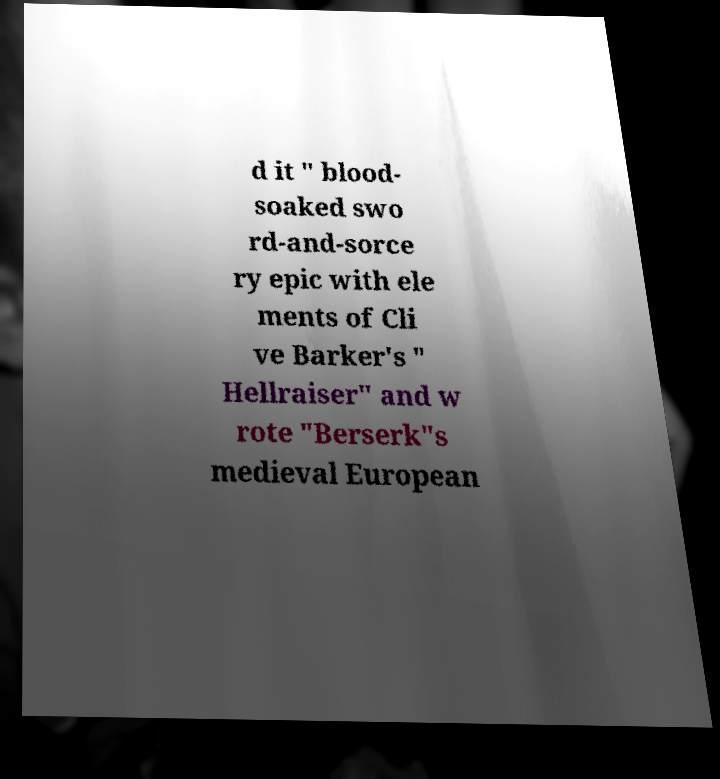Can you read and provide the text displayed in the image?This photo seems to have some interesting text. Can you extract and type it out for me? d it " blood- soaked swo rd-and-sorce ry epic with ele ments of Cli ve Barker's " Hellraiser" and w rote "Berserk"s medieval European 